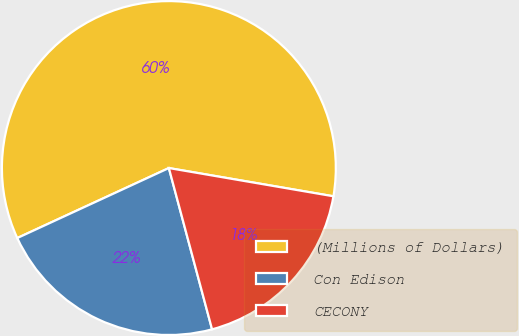Convert chart. <chart><loc_0><loc_0><loc_500><loc_500><pie_chart><fcel>(Millions of Dollars)<fcel>Con Edison<fcel>CECONY<nl><fcel>59.59%<fcel>22.28%<fcel>18.13%<nl></chart> 